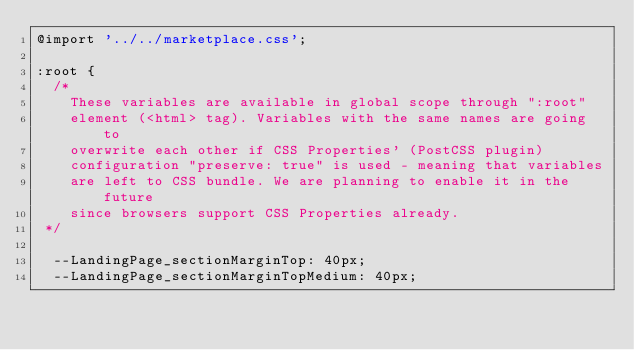Convert code to text. <code><loc_0><loc_0><loc_500><loc_500><_CSS_>@import '../../marketplace.css';

:root {
  /*
    These variables are available in global scope through ":root"
    element (<html> tag). Variables with the same names are going to
    overwrite each other if CSS Properties' (PostCSS plugin)
    configuration "preserve: true" is used - meaning that variables
    are left to CSS bundle. We are planning to enable it in the future
    since browsers support CSS Properties already.
 */

  --LandingPage_sectionMarginTop: 40px;
  --LandingPage_sectionMarginTopMedium: 40px;</code> 